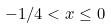Convert formula to latex. <formula><loc_0><loc_0><loc_500><loc_500>- 1 / 4 < x \leq 0</formula> 